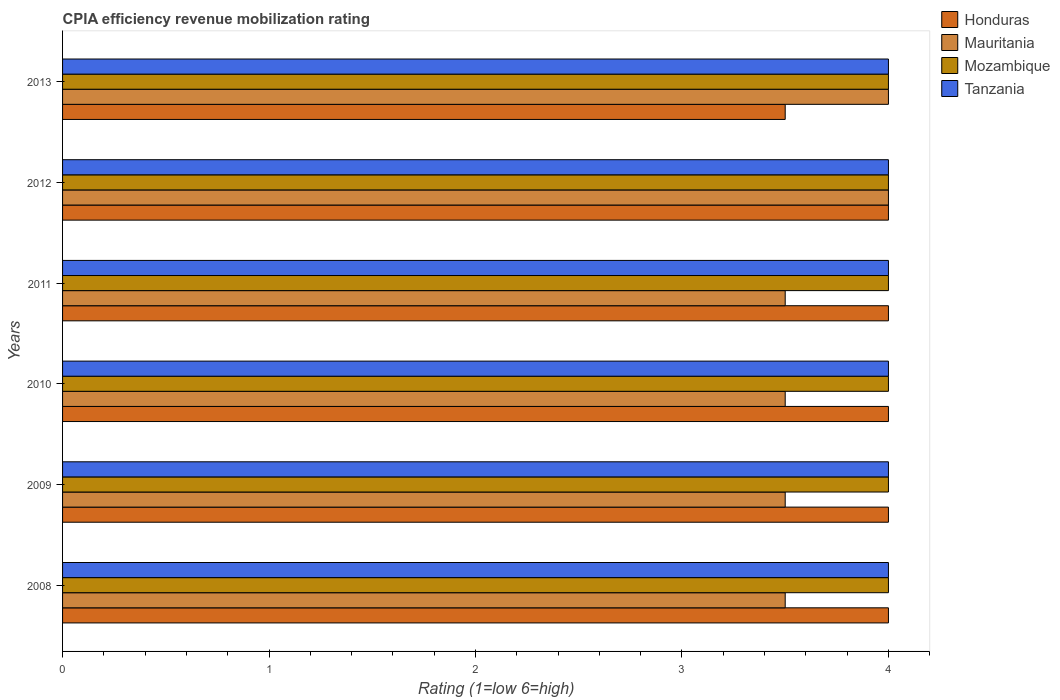Are the number of bars per tick equal to the number of legend labels?
Your answer should be very brief. Yes. What is the label of the 1st group of bars from the top?
Your answer should be compact. 2013. In how many cases, is the number of bars for a given year not equal to the number of legend labels?
Make the answer very short. 0. Across all years, what is the minimum CPIA rating in Tanzania?
Give a very brief answer. 4. In the year 2013, what is the difference between the CPIA rating in Honduras and CPIA rating in Tanzania?
Keep it short and to the point. -0.5. What is the ratio of the CPIA rating in Honduras in 2012 to that in 2013?
Offer a terse response. 1.14. Is the difference between the CPIA rating in Honduras in 2009 and 2011 greater than the difference between the CPIA rating in Tanzania in 2009 and 2011?
Your answer should be very brief. No. What is the difference between the highest and the second highest CPIA rating in Honduras?
Give a very brief answer. 0. Is it the case that in every year, the sum of the CPIA rating in Mozambique and CPIA rating in Tanzania is greater than the sum of CPIA rating in Honduras and CPIA rating in Mauritania?
Ensure brevity in your answer.  No. What does the 3rd bar from the top in 2011 represents?
Give a very brief answer. Mauritania. What does the 2nd bar from the bottom in 2011 represents?
Ensure brevity in your answer.  Mauritania. Is it the case that in every year, the sum of the CPIA rating in Honduras and CPIA rating in Mauritania is greater than the CPIA rating in Tanzania?
Give a very brief answer. Yes. How many years are there in the graph?
Your answer should be very brief. 6. What is the difference between two consecutive major ticks on the X-axis?
Your response must be concise. 1. How many legend labels are there?
Offer a very short reply. 4. What is the title of the graph?
Give a very brief answer. CPIA efficiency revenue mobilization rating. What is the label or title of the Y-axis?
Offer a very short reply. Years. What is the Rating (1=low 6=high) of Honduras in 2008?
Offer a very short reply. 4. What is the Rating (1=low 6=high) of Mauritania in 2008?
Your answer should be compact. 3.5. What is the Rating (1=low 6=high) of Tanzania in 2008?
Make the answer very short. 4. What is the Rating (1=low 6=high) in Honduras in 2009?
Offer a terse response. 4. What is the Rating (1=low 6=high) in Mauritania in 2009?
Give a very brief answer. 3.5. What is the Rating (1=low 6=high) of Honduras in 2010?
Make the answer very short. 4. What is the Rating (1=low 6=high) of Mauritania in 2010?
Offer a terse response. 3.5. What is the Rating (1=low 6=high) in Mozambique in 2010?
Ensure brevity in your answer.  4. What is the Rating (1=low 6=high) in Tanzania in 2010?
Give a very brief answer. 4. What is the Rating (1=low 6=high) in Mauritania in 2011?
Ensure brevity in your answer.  3.5. What is the Rating (1=low 6=high) in Tanzania in 2011?
Your response must be concise. 4. What is the Rating (1=low 6=high) of Honduras in 2012?
Your answer should be compact. 4. What is the Rating (1=low 6=high) of Mozambique in 2012?
Offer a terse response. 4. What is the Rating (1=low 6=high) in Honduras in 2013?
Offer a very short reply. 3.5. What is the Rating (1=low 6=high) in Mauritania in 2013?
Offer a very short reply. 4. Across all years, what is the maximum Rating (1=low 6=high) in Mauritania?
Offer a very short reply. 4. Across all years, what is the maximum Rating (1=low 6=high) in Tanzania?
Your answer should be very brief. 4. Across all years, what is the minimum Rating (1=low 6=high) of Mozambique?
Provide a short and direct response. 4. What is the total Rating (1=low 6=high) in Mauritania in the graph?
Ensure brevity in your answer.  22. What is the difference between the Rating (1=low 6=high) in Mauritania in 2008 and that in 2009?
Your answer should be compact. 0. What is the difference between the Rating (1=low 6=high) of Mozambique in 2008 and that in 2009?
Your answer should be compact. 0. What is the difference between the Rating (1=low 6=high) in Tanzania in 2008 and that in 2009?
Keep it short and to the point. 0. What is the difference between the Rating (1=low 6=high) in Honduras in 2008 and that in 2010?
Your answer should be very brief. 0. What is the difference between the Rating (1=low 6=high) in Mauritania in 2008 and that in 2010?
Offer a terse response. 0. What is the difference between the Rating (1=low 6=high) of Mauritania in 2008 and that in 2011?
Your response must be concise. 0. What is the difference between the Rating (1=low 6=high) of Mozambique in 2008 and that in 2011?
Offer a very short reply. 0. What is the difference between the Rating (1=low 6=high) in Tanzania in 2008 and that in 2011?
Your answer should be compact. 0. What is the difference between the Rating (1=low 6=high) of Tanzania in 2008 and that in 2012?
Offer a very short reply. 0. What is the difference between the Rating (1=low 6=high) of Mauritania in 2008 and that in 2013?
Your response must be concise. -0.5. What is the difference between the Rating (1=low 6=high) of Tanzania in 2008 and that in 2013?
Give a very brief answer. 0. What is the difference between the Rating (1=low 6=high) of Honduras in 2009 and that in 2010?
Offer a terse response. 0. What is the difference between the Rating (1=low 6=high) of Honduras in 2009 and that in 2011?
Offer a very short reply. 0. What is the difference between the Rating (1=low 6=high) in Mauritania in 2009 and that in 2011?
Your response must be concise. 0. What is the difference between the Rating (1=low 6=high) of Mozambique in 2009 and that in 2012?
Make the answer very short. 0. What is the difference between the Rating (1=low 6=high) in Honduras in 2009 and that in 2013?
Make the answer very short. 0.5. What is the difference between the Rating (1=low 6=high) in Mauritania in 2009 and that in 2013?
Offer a very short reply. -0.5. What is the difference between the Rating (1=low 6=high) of Honduras in 2010 and that in 2011?
Offer a terse response. 0. What is the difference between the Rating (1=low 6=high) in Mauritania in 2010 and that in 2011?
Keep it short and to the point. 0. What is the difference between the Rating (1=low 6=high) in Mozambique in 2010 and that in 2011?
Provide a short and direct response. 0. What is the difference between the Rating (1=low 6=high) in Tanzania in 2010 and that in 2011?
Offer a terse response. 0. What is the difference between the Rating (1=low 6=high) of Honduras in 2010 and that in 2012?
Make the answer very short. 0. What is the difference between the Rating (1=low 6=high) in Mauritania in 2010 and that in 2012?
Offer a terse response. -0.5. What is the difference between the Rating (1=low 6=high) of Mozambique in 2010 and that in 2012?
Your response must be concise. 0. What is the difference between the Rating (1=low 6=high) of Honduras in 2010 and that in 2013?
Provide a succinct answer. 0.5. What is the difference between the Rating (1=low 6=high) in Tanzania in 2010 and that in 2013?
Offer a very short reply. 0. What is the difference between the Rating (1=low 6=high) in Honduras in 2011 and that in 2012?
Provide a short and direct response. 0. What is the difference between the Rating (1=low 6=high) in Mauritania in 2011 and that in 2012?
Ensure brevity in your answer.  -0.5. What is the difference between the Rating (1=low 6=high) of Mozambique in 2011 and that in 2012?
Provide a short and direct response. 0. What is the difference between the Rating (1=low 6=high) in Honduras in 2011 and that in 2013?
Give a very brief answer. 0.5. What is the difference between the Rating (1=low 6=high) of Mauritania in 2011 and that in 2013?
Make the answer very short. -0.5. What is the difference between the Rating (1=low 6=high) in Tanzania in 2011 and that in 2013?
Provide a short and direct response. 0. What is the difference between the Rating (1=low 6=high) of Mozambique in 2012 and that in 2013?
Provide a succinct answer. 0. What is the difference between the Rating (1=low 6=high) in Honduras in 2008 and the Rating (1=low 6=high) in Tanzania in 2009?
Give a very brief answer. 0. What is the difference between the Rating (1=low 6=high) in Mozambique in 2008 and the Rating (1=low 6=high) in Tanzania in 2009?
Provide a short and direct response. 0. What is the difference between the Rating (1=low 6=high) of Honduras in 2008 and the Rating (1=low 6=high) of Mauritania in 2010?
Keep it short and to the point. 0.5. What is the difference between the Rating (1=low 6=high) in Honduras in 2008 and the Rating (1=low 6=high) in Tanzania in 2010?
Keep it short and to the point. 0. What is the difference between the Rating (1=low 6=high) in Mauritania in 2008 and the Rating (1=low 6=high) in Mozambique in 2010?
Provide a succinct answer. -0.5. What is the difference between the Rating (1=low 6=high) of Mauritania in 2008 and the Rating (1=low 6=high) of Tanzania in 2010?
Ensure brevity in your answer.  -0.5. What is the difference between the Rating (1=low 6=high) in Mozambique in 2008 and the Rating (1=low 6=high) in Tanzania in 2010?
Give a very brief answer. 0. What is the difference between the Rating (1=low 6=high) in Honduras in 2008 and the Rating (1=low 6=high) in Mauritania in 2011?
Make the answer very short. 0.5. What is the difference between the Rating (1=low 6=high) of Mozambique in 2008 and the Rating (1=low 6=high) of Tanzania in 2011?
Your answer should be compact. 0. What is the difference between the Rating (1=low 6=high) in Honduras in 2008 and the Rating (1=low 6=high) in Tanzania in 2012?
Ensure brevity in your answer.  0. What is the difference between the Rating (1=low 6=high) of Mauritania in 2008 and the Rating (1=low 6=high) of Mozambique in 2012?
Give a very brief answer. -0.5. What is the difference between the Rating (1=low 6=high) in Mauritania in 2008 and the Rating (1=low 6=high) in Tanzania in 2012?
Offer a terse response. -0.5. What is the difference between the Rating (1=low 6=high) of Honduras in 2008 and the Rating (1=low 6=high) of Mozambique in 2013?
Your answer should be very brief. 0. What is the difference between the Rating (1=low 6=high) of Mozambique in 2008 and the Rating (1=low 6=high) of Tanzania in 2013?
Provide a succinct answer. 0. What is the difference between the Rating (1=low 6=high) of Honduras in 2009 and the Rating (1=low 6=high) of Mauritania in 2010?
Your response must be concise. 0.5. What is the difference between the Rating (1=low 6=high) in Honduras in 2009 and the Rating (1=low 6=high) in Mozambique in 2010?
Ensure brevity in your answer.  0. What is the difference between the Rating (1=low 6=high) of Honduras in 2009 and the Rating (1=low 6=high) of Mozambique in 2011?
Give a very brief answer. 0. What is the difference between the Rating (1=low 6=high) in Mauritania in 2009 and the Rating (1=low 6=high) in Tanzania in 2011?
Keep it short and to the point. -0.5. What is the difference between the Rating (1=low 6=high) in Honduras in 2009 and the Rating (1=low 6=high) in Mauritania in 2012?
Provide a succinct answer. 0. What is the difference between the Rating (1=low 6=high) of Honduras in 2009 and the Rating (1=low 6=high) of Tanzania in 2012?
Give a very brief answer. 0. What is the difference between the Rating (1=low 6=high) of Mozambique in 2009 and the Rating (1=low 6=high) of Tanzania in 2012?
Provide a short and direct response. 0. What is the difference between the Rating (1=low 6=high) of Honduras in 2009 and the Rating (1=low 6=high) of Mozambique in 2013?
Keep it short and to the point. 0. What is the difference between the Rating (1=low 6=high) in Mauritania in 2009 and the Rating (1=low 6=high) in Tanzania in 2013?
Keep it short and to the point. -0.5. What is the difference between the Rating (1=low 6=high) in Mozambique in 2009 and the Rating (1=low 6=high) in Tanzania in 2013?
Provide a short and direct response. 0. What is the difference between the Rating (1=low 6=high) in Honduras in 2010 and the Rating (1=low 6=high) in Mauritania in 2011?
Your answer should be very brief. 0.5. What is the difference between the Rating (1=low 6=high) of Mauritania in 2010 and the Rating (1=low 6=high) of Mozambique in 2011?
Your response must be concise. -0.5. What is the difference between the Rating (1=low 6=high) of Mozambique in 2010 and the Rating (1=low 6=high) of Tanzania in 2011?
Make the answer very short. 0. What is the difference between the Rating (1=low 6=high) of Honduras in 2010 and the Rating (1=low 6=high) of Tanzania in 2012?
Offer a terse response. 0. What is the difference between the Rating (1=low 6=high) in Mauritania in 2010 and the Rating (1=low 6=high) in Mozambique in 2012?
Offer a terse response. -0.5. What is the difference between the Rating (1=low 6=high) in Mauritania in 2010 and the Rating (1=low 6=high) in Tanzania in 2012?
Provide a succinct answer. -0.5. What is the difference between the Rating (1=low 6=high) of Honduras in 2010 and the Rating (1=low 6=high) of Mauritania in 2013?
Provide a succinct answer. 0. What is the difference between the Rating (1=low 6=high) in Mauritania in 2010 and the Rating (1=low 6=high) in Mozambique in 2013?
Your answer should be very brief. -0.5. What is the difference between the Rating (1=low 6=high) in Mauritania in 2010 and the Rating (1=low 6=high) in Tanzania in 2013?
Ensure brevity in your answer.  -0.5. What is the difference between the Rating (1=low 6=high) in Mozambique in 2010 and the Rating (1=low 6=high) in Tanzania in 2013?
Provide a short and direct response. 0. What is the difference between the Rating (1=low 6=high) in Honduras in 2011 and the Rating (1=low 6=high) in Mauritania in 2012?
Ensure brevity in your answer.  0. What is the difference between the Rating (1=low 6=high) in Honduras in 2011 and the Rating (1=low 6=high) in Mozambique in 2012?
Provide a succinct answer. 0. What is the difference between the Rating (1=low 6=high) in Honduras in 2011 and the Rating (1=low 6=high) in Tanzania in 2013?
Give a very brief answer. 0. What is the difference between the Rating (1=low 6=high) in Honduras in 2012 and the Rating (1=low 6=high) in Mauritania in 2013?
Keep it short and to the point. 0. What is the difference between the Rating (1=low 6=high) in Honduras in 2012 and the Rating (1=low 6=high) in Mozambique in 2013?
Provide a succinct answer. 0. What is the difference between the Rating (1=low 6=high) of Honduras in 2012 and the Rating (1=low 6=high) of Tanzania in 2013?
Your response must be concise. 0. What is the difference between the Rating (1=low 6=high) in Mauritania in 2012 and the Rating (1=low 6=high) in Tanzania in 2013?
Provide a short and direct response. 0. What is the difference between the Rating (1=low 6=high) in Mozambique in 2012 and the Rating (1=low 6=high) in Tanzania in 2013?
Ensure brevity in your answer.  0. What is the average Rating (1=low 6=high) in Honduras per year?
Make the answer very short. 3.92. What is the average Rating (1=low 6=high) of Mauritania per year?
Ensure brevity in your answer.  3.67. What is the average Rating (1=low 6=high) of Mozambique per year?
Your answer should be very brief. 4. What is the average Rating (1=low 6=high) in Tanzania per year?
Your answer should be very brief. 4. In the year 2008, what is the difference between the Rating (1=low 6=high) in Honduras and Rating (1=low 6=high) in Mauritania?
Give a very brief answer. 0.5. In the year 2008, what is the difference between the Rating (1=low 6=high) of Honduras and Rating (1=low 6=high) of Mozambique?
Keep it short and to the point. 0. In the year 2008, what is the difference between the Rating (1=low 6=high) of Honduras and Rating (1=low 6=high) of Tanzania?
Your answer should be compact. 0. In the year 2008, what is the difference between the Rating (1=low 6=high) in Mauritania and Rating (1=low 6=high) in Tanzania?
Offer a terse response. -0.5. In the year 2009, what is the difference between the Rating (1=low 6=high) of Honduras and Rating (1=low 6=high) of Mauritania?
Your response must be concise. 0.5. In the year 2009, what is the difference between the Rating (1=low 6=high) in Honduras and Rating (1=low 6=high) in Tanzania?
Ensure brevity in your answer.  0. In the year 2009, what is the difference between the Rating (1=low 6=high) in Mauritania and Rating (1=low 6=high) in Mozambique?
Ensure brevity in your answer.  -0.5. In the year 2009, what is the difference between the Rating (1=low 6=high) of Mauritania and Rating (1=low 6=high) of Tanzania?
Ensure brevity in your answer.  -0.5. In the year 2010, what is the difference between the Rating (1=low 6=high) in Honduras and Rating (1=low 6=high) in Mauritania?
Offer a terse response. 0.5. In the year 2010, what is the difference between the Rating (1=low 6=high) of Honduras and Rating (1=low 6=high) of Mozambique?
Ensure brevity in your answer.  0. In the year 2010, what is the difference between the Rating (1=low 6=high) in Mauritania and Rating (1=low 6=high) in Tanzania?
Give a very brief answer. -0.5. In the year 2011, what is the difference between the Rating (1=low 6=high) of Mauritania and Rating (1=low 6=high) of Tanzania?
Offer a very short reply. -0.5. In the year 2011, what is the difference between the Rating (1=low 6=high) in Mozambique and Rating (1=low 6=high) in Tanzania?
Make the answer very short. 0. In the year 2012, what is the difference between the Rating (1=low 6=high) in Mauritania and Rating (1=low 6=high) in Mozambique?
Give a very brief answer. 0. In the year 2013, what is the difference between the Rating (1=low 6=high) in Honduras and Rating (1=low 6=high) in Mauritania?
Your response must be concise. -0.5. In the year 2013, what is the difference between the Rating (1=low 6=high) of Honduras and Rating (1=low 6=high) of Mozambique?
Your answer should be very brief. -0.5. In the year 2013, what is the difference between the Rating (1=low 6=high) in Mauritania and Rating (1=low 6=high) in Mozambique?
Make the answer very short. 0. What is the ratio of the Rating (1=low 6=high) in Mauritania in 2008 to that in 2009?
Provide a succinct answer. 1. What is the ratio of the Rating (1=low 6=high) in Mozambique in 2008 to that in 2009?
Offer a very short reply. 1. What is the ratio of the Rating (1=low 6=high) of Mauritania in 2008 to that in 2010?
Offer a terse response. 1. What is the ratio of the Rating (1=low 6=high) of Mozambique in 2008 to that in 2010?
Make the answer very short. 1. What is the ratio of the Rating (1=low 6=high) in Honduras in 2008 to that in 2011?
Make the answer very short. 1. What is the ratio of the Rating (1=low 6=high) in Mauritania in 2008 to that in 2011?
Your answer should be compact. 1. What is the ratio of the Rating (1=low 6=high) of Tanzania in 2008 to that in 2011?
Your answer should be very brief. 1. What is the ratio of the Rating (1=low 6=high) of Honduras in 2008 to that in 2012?
Your response must be concise. 1. What is the ratio of the Rating (1=low 6=high) in Mauritania in 2008 to that in 2012?
Provide a short and direct response. 0.88. What is the ratio of the Rating (1=low 6=high) in Tanzania in 2008 to that in 2012?
Your answer should be very brief. 1. What is the ratio of the Rating (1=low 6=high) in Mozambique in 2008 to that in 2013?
Provide a succinct answer. 1. What is the ratio of the Rating (1=low 6=high) of Honduras in 2009 to that in 2010?
Offer a very short reply. 1. What is the ratio of the Rating (1=low 6=high) in Mozambique in 2009 to that in 2010?
Your response must be concise. 1. What is the ratio of the Rating (1=low 6=high) of Honduras in 2009 to that in 2011?
Your answer should be compact. 1. What is the ratio of the Rating (1=low 6=high) of Mozambique in 2009 to that in 2011?
Provide a succinct answer. 1. What is the ratio of the Rating (1=low 6=high) of Tanzania in 2009 to that in 2011?
Offer a very short reply. 1. What is the ratio of the Rating (1=low 6=high) in Honduras in 2009 to that in 2012?
Offer a terse response. 1. What is the ratio of the Rating (1=low 6=high) in Mauritania in 2009 to that in 2012?
Provide a short and direct response. 0.88. What is the ratio of the Rating (1=low 6=high) of Tanzania in 2009 to that in 2012?
Provide a short and direct response. 1. What is the ratio of the Rating (1=low 6=high) of Tanzania in 2010 to that in 2011?
Keep it short and to the point. 1. What is the ratio of the Rating (1=low 6=high) of Tanzania in 2010 to that in 2012?
Make the answer very short. 1. What is the ratio of the Rating (1=low 6=high) of Honduras in 2010 to that in 2013?
Ensure brevity in your answer.  1.14. What is the ratio of the Rating (1=low 6=high) of Honduras in 2011 to that in 2012?
Ensure brevity in your answer.  1. What is the ratio of the Rating (1=low 6=high) in Mozambique in 2011 to that in 2012?
Provide a succinct answer. 1. What is the ratio of the Rating (1=low 6=high) in Mauritania in 2011 to that in 2013?
Your response must be concise. 0.88. What is the ratio of the Rating (1=low 6=high) in Mozambique in 2012 to that in 2013?
Keep it short and to the point. 1. What is the ratio of the Rating (1=low 6=high) of Tanzania in 2012 to that in 2013?
Make the answer very short. 1. What is the difference between the highest and the lowest Rating (1=low 6=high) of Mauritania?
Ensure brevity in your answer.  0.5. What is the difference between the highest and the lowest Rating (1=low 6=high) in Tanzania?
Ensure brevity in your answer.  0. 